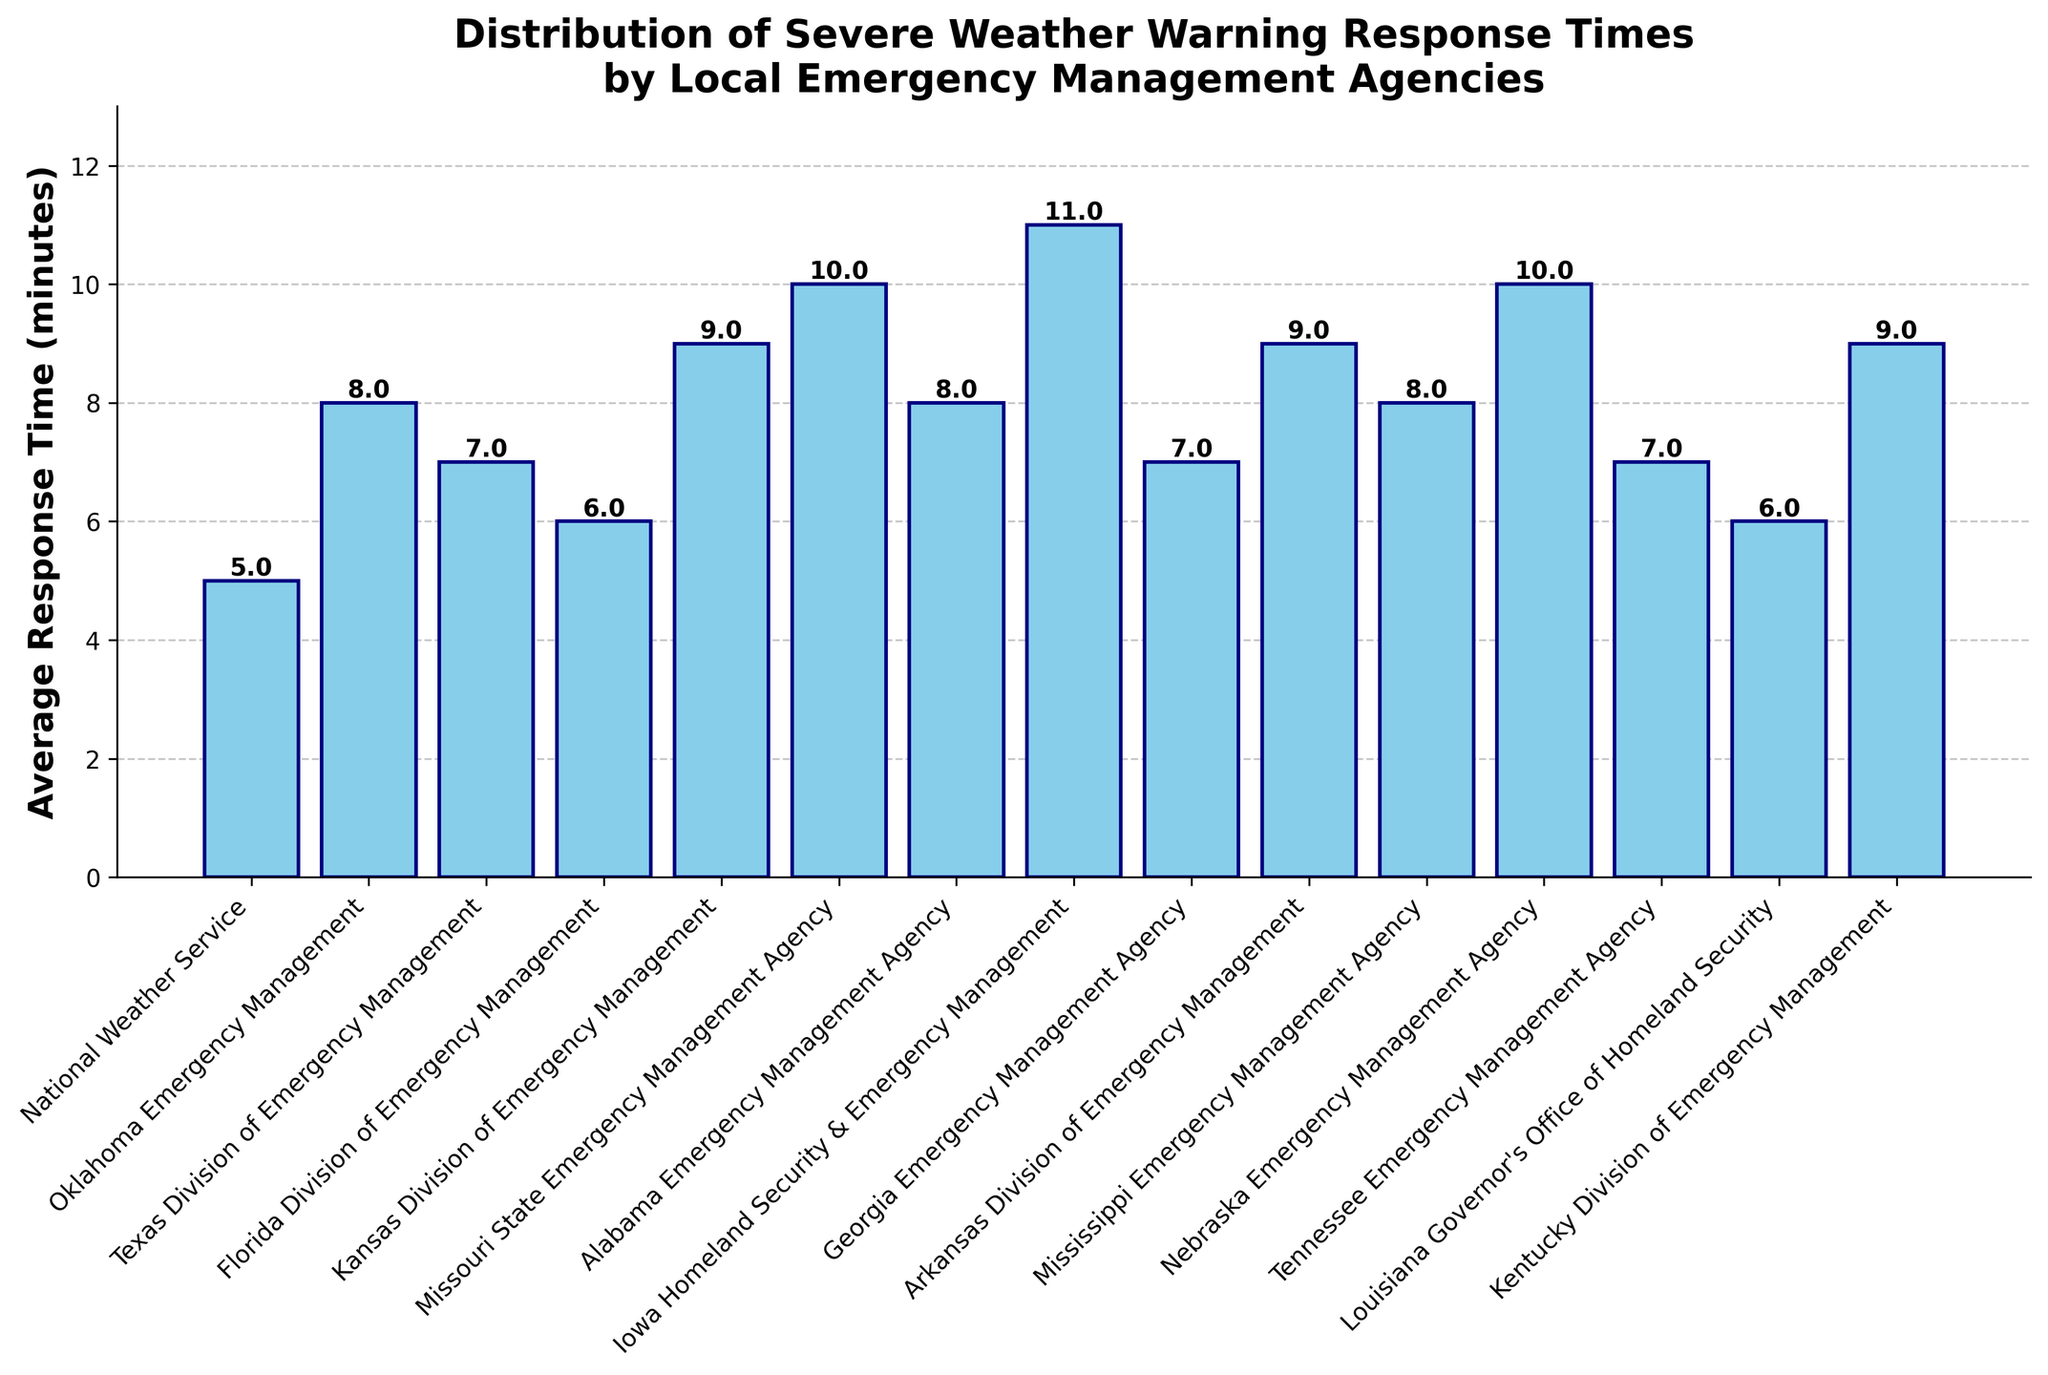What is the average response time of the Missouri State Emergency Management Agency? Look at the height of the bar corresponding to the Missouri State Emergency Management Agency. The value shown is 10.0 minutes.
Answer: 10.0 minutes Which agency has the shortest response time and what is it? Compare the heights of all the bars. The National Weather Service has the shortest bar with a value of 5.0 minutes.
Answer: National Weather Service - 5.0 minutes How much longer is the response time of the Iowa Homeland Security & Emergency Management compared to the Florida Division of Emergency Management? Find the height of the bars for both agencies. Iowa’s bar is 11.0 minutes and Florida’s is 6.0 minutes. Subtract 6.0 from 11.0 to get the difference.
Answer: 5.0 minutes What is the combined response time of the Texas Division of Emergency Management and the Georgia Emergency Management Agency? Add the heights of the bars for Texas (7.0 minutes) and Georgia (7.0 minutes). The sum is 7.0 + 7.0.
Answer: 14.0 minutes What is the average response time across all agencies? Add the response times from all the agencies and then divide by the number of agencies. The total is 128.0 minutes for 15 agencies, yielding 128.0 / 15.0.
Answer: 8.53 minutes Which agency has the highest response time and how much is it? Compare the heights of all the bars. The Iowa Homeland Security & Emergency Management bar is the tallest at 11.0 minutes.
Answer: Iowa Homeland Security & Emergency Management - 11.0 minutes How many agencies have a response time of 7.0 minutes? Count the bars that are at the height corresponding to 7.0 minutes. Texas, Georgia, and Tennessee all have response times of 7.0 minutes.
Answer: 3 agencies If we remove the shortest and longest response times, what is the new average response time? First, remove the shortest (National Weather Service - 5.0 minutes) and longest (Iowa Homeland Security & Emergency Management - 11.0 minutes) response times. The new sum is 128.0 - 5.0 - 11.0 = 112.0 minutes. There are now 13 agencies, so 112.0 divided by 13.0 is the average.
Answer: 8.62 minutes What is the median response time of all the agencies? List all response times in ascending order [5.0, 6.0, 6.0, 7.0, 7.0, 7.0, 8.0, 8.0, 8.0, 9.0, 9.0, 9.0, 10.0, 10.0, 11.0]. The middle value (8.0) in this ordered list is the median when there are 15 values.
Answer: 8.0 minutes 